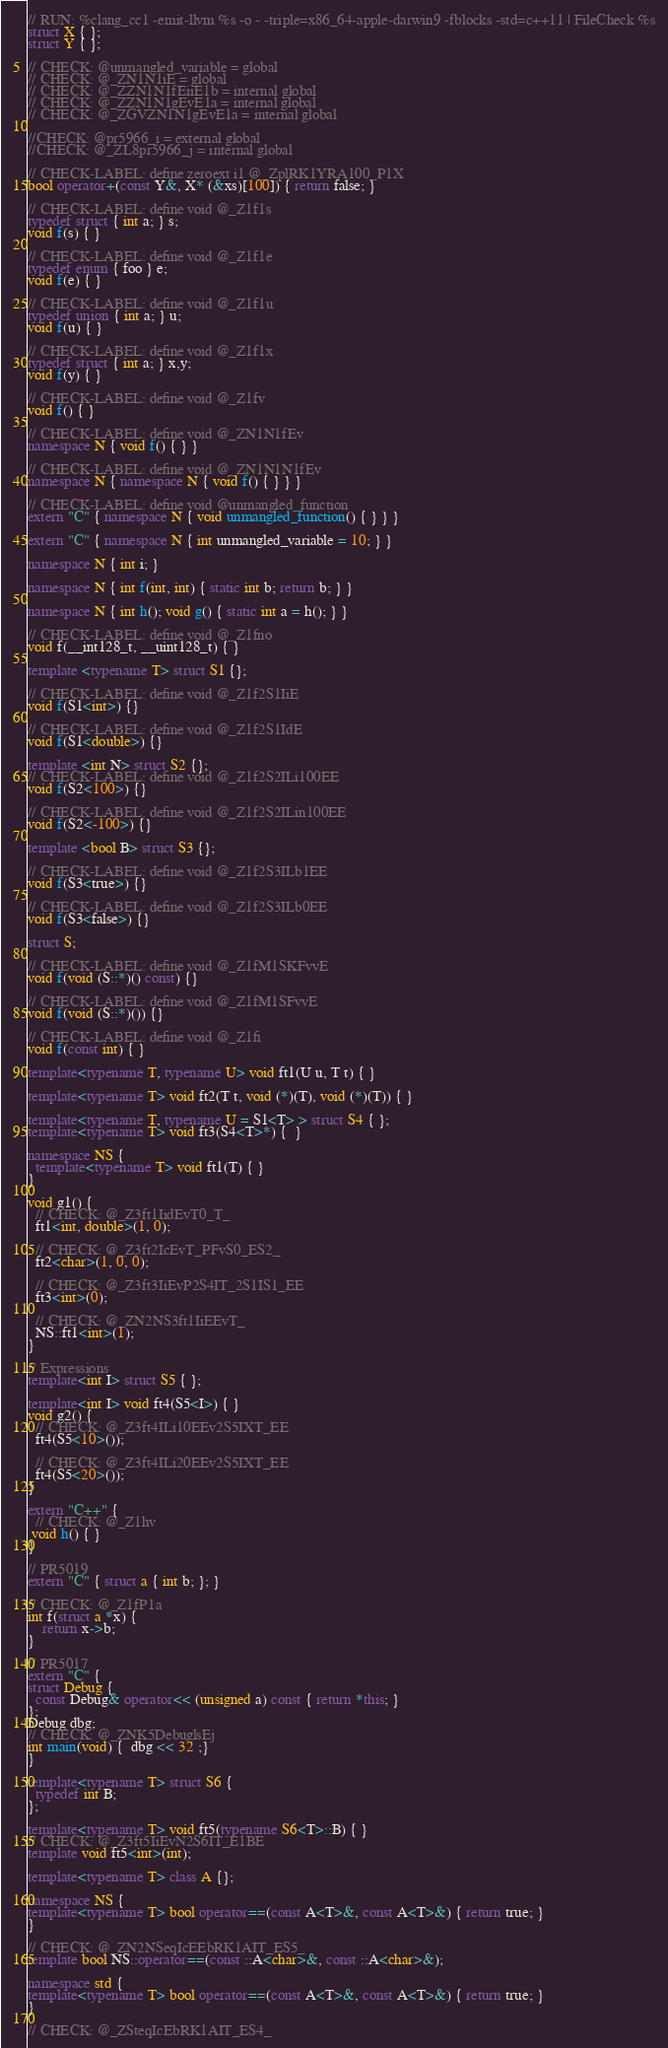Convert code to text. <code><loc_0><loc_0><loc_500><loc_500><_C++_>// RUN: %clang_cc1 -emit-llvm %s -o - -triple=x86_64-apple-darwin9 -fblocks -std=c++11 | FileCheck %s
struct X { };
struct Y { };

// CHECK: @unmangled_variable = global
// CHECK: @_ZN1N1iE = global
// CHECK: @_ZZN1N1fEiiE1b = internal global
// CHECK: @_ZZN1N1gEvE1a = internal global
// CHECK: @_ZGVZN1N1gEvE1a = internal global

//CHECK: @pr5966_i = external global
//CHECK: @_ZL8pr5966_j = internal global

// CHECK-LABEL: define zeroext i1 @_ZplRK1YRA100_P1X
bool operator+(const Y&, X* (&xs)[100]) { return false; }

// CHECK-LABEL: define void @_Z1f1s
typedef struct { int a; } s;
void f(s) { }

// CHECK-LABEL: define void @_Z1f1e
typedef enum { foo } e;
void f(e) { }

// CHECK-LABEL: define void @_Z1f1u
typedef union { int a; } u;
void f(u) { }

// CHECK-LABEL: define void @_Z1f1x
typedef struct { int a; } x,y;
void f(y) { }

// CHECK-LABEL: define void @_Z1fv
void f() { }

// CHECK-LABEL: define void @_ZN1N1fEv
namespace N { void f() { } }

// CHECK-LABEL: define void @_ZN1N1N1fEv
namespace N { namespace N { void f() { } } }

// CHECK-LABEL: define void @unmangled_function
extern "C" { namespace N { void unmangled_function() { } } }

extern "C" { namespace N { int unmangled_variable = 10; } }

namespace N { int i; }

namespace N { int f(int, int) { static int b; return b; } }

namespace N { int h(); void g() { static int a = h(); } }

// CHECK-LABEL: define void @_Z1fno
void f(__int128_t, __uint128_t) { } 

template <typename T> struct S1 {};

// CHECK-LABEL: define void @_Z1f2S1IiE
void f(S1<int>) {}

// CHECK-LABEL: define void @_Z1f2S1IdE
void f(S1<double>) {}

template <int N> struct S2 {};
// CHECK-LABEL: define void @_Z1f2S2ILi100EE
void f(S2<100>) {}

// CHECK-LABEL: define void @_Z1f2S2ILin100EE
void f(S2<-100>) {}

template <bool B> struct S3 {};

// CHECK-LABEL: define void @_Z1f2S3ILb1EE
void f(S3<true>) {}

// CHECK-LABEL: define void @_Z1f2S3ILb0EE
void f(S3<false>) {}

struct S;

// CHECK-LABEL: define void @_Z1fM1SKFvvE
void f(void (S::*)() const) {}

// CHECK-LABEL: define void @_Z1fM1SFvvE
void f(void (S::*)()) {}

// CHECK-LABEL: define void @_Z1fi
void f(const int) { }

template<typename T, typename U> void ft1(U u, T t) { }

template<typename T> void ft2(T t, void (*)(T), void (*)(T)) { }

template<typename T, typename U = S1<T> > struct S4 { };
template<typename T> void ft3(S4<T>*) {  }

namespace NS {
  template<typename T> void ft1(T) { }
}

void g1() {
  // CHECK: @_Z3ft1IidEvT0_T_
  ft1<int, double>(1, 0);
  
  // CHECK: @_Z3ft2IcEvT_PFvS0_ES2_
  ft2<char>(1, 0, 0);
  
  // CHECK: @_Z3ft3IiEvP2S4IT_2S1IS1_EE
  ft3<int>(0);
  
  // CHECK: @_ZN2NS3ft1IiEEvT_
  NS::ft1<int>(1);
}

// Expressions
template<int I> struct S5 { };

template<int I> void ft4(S5<I>) { }
void g2() {
  // CHECK: @_Z3ft4ILi10EEv2S5IXT_EE
  ft4(S5<10>());
  
  // CHECK: @_Z3ft4ILi20EEv2S5IXT_EE
  ft4(S5<20>());
}

extern "C++" {
  // CHECK: @_Z1hv
 void h() { } 
}

// PR5019
extern "C" { struct a { int b; }; }

// CHECK: @_Z1fP1a
int f(struct a *x) {
    return x->b;
}

// PR5017
extern "C" {
struct Debug {
  const Debug& operator<< (unsigned a) const { return *this; }
};
Debug dbg;
// CHECK: @_ZNK5DebuglsEj
int main(void) {  dbg << 32 ;}
}

template<typename T> struct S6 {
  typedef int B;
};

template<typename T> void ft5(typename S6<T>::B) { }
// CHECK: @_Z3ft5IiEvN2S6IT_E1BE
template void ft5<int>(int);

template<typename T> class A {};

namespace NS {
template<typename T> bool operator==(const A<T>&, const A<T>&) { return true; }
}

// CHECK: @_ZN2NSeqIcEEbRK1AIT_ES5_
template bool NS::operator==(const ::A<char>&, const ::A<char>&);

namespace std {
template<typename T> bool operator==(const A<T>&, const A<T>&) { return true; }
}

// CHECK: @_ZSteqIcEbRK1AIT_ES4_</code> 